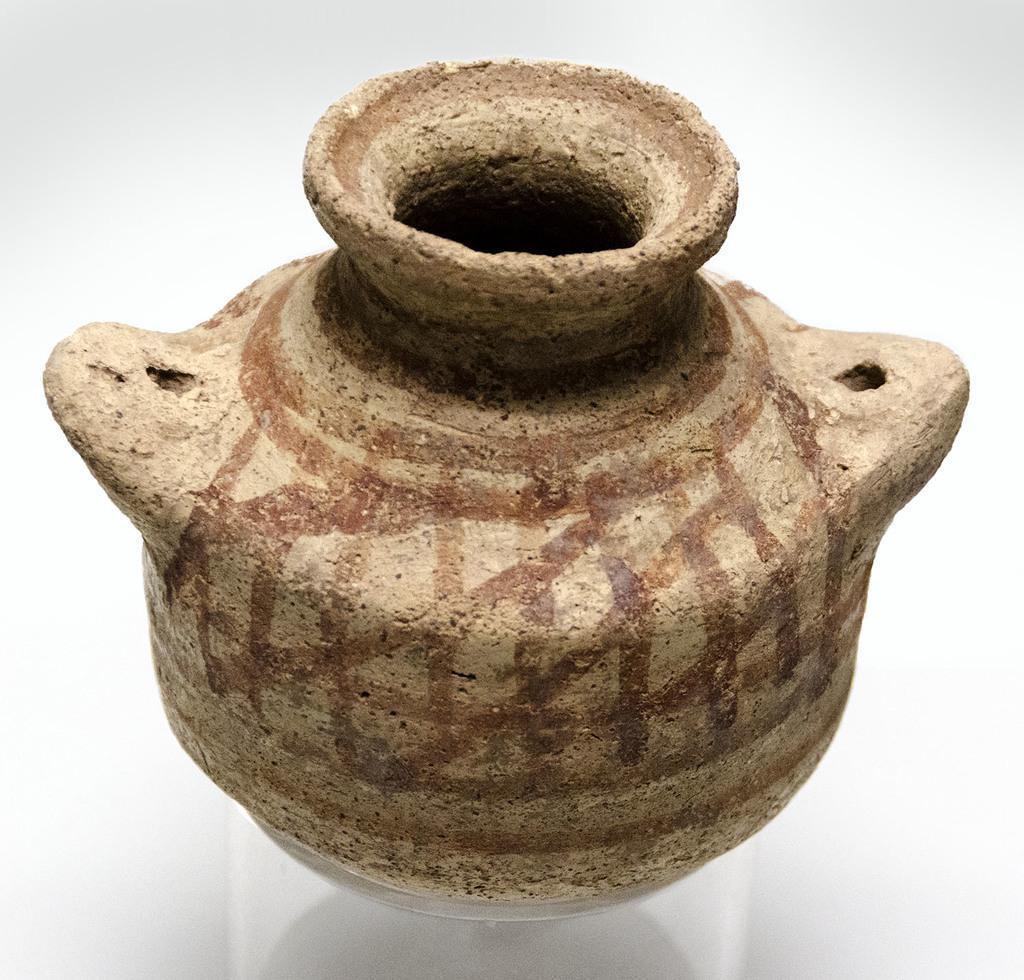Could you give a brief overview of what you see in this image? In this image I can see the pot which is in brown color. It is on the white color surface. 